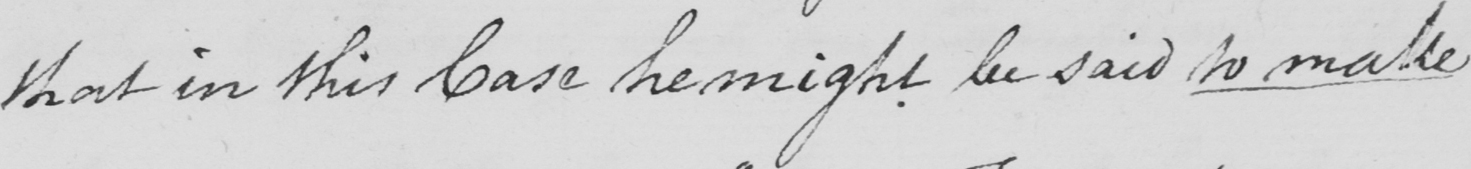Can you read and transcribe this handwriting? that in this Case he might be said to make 